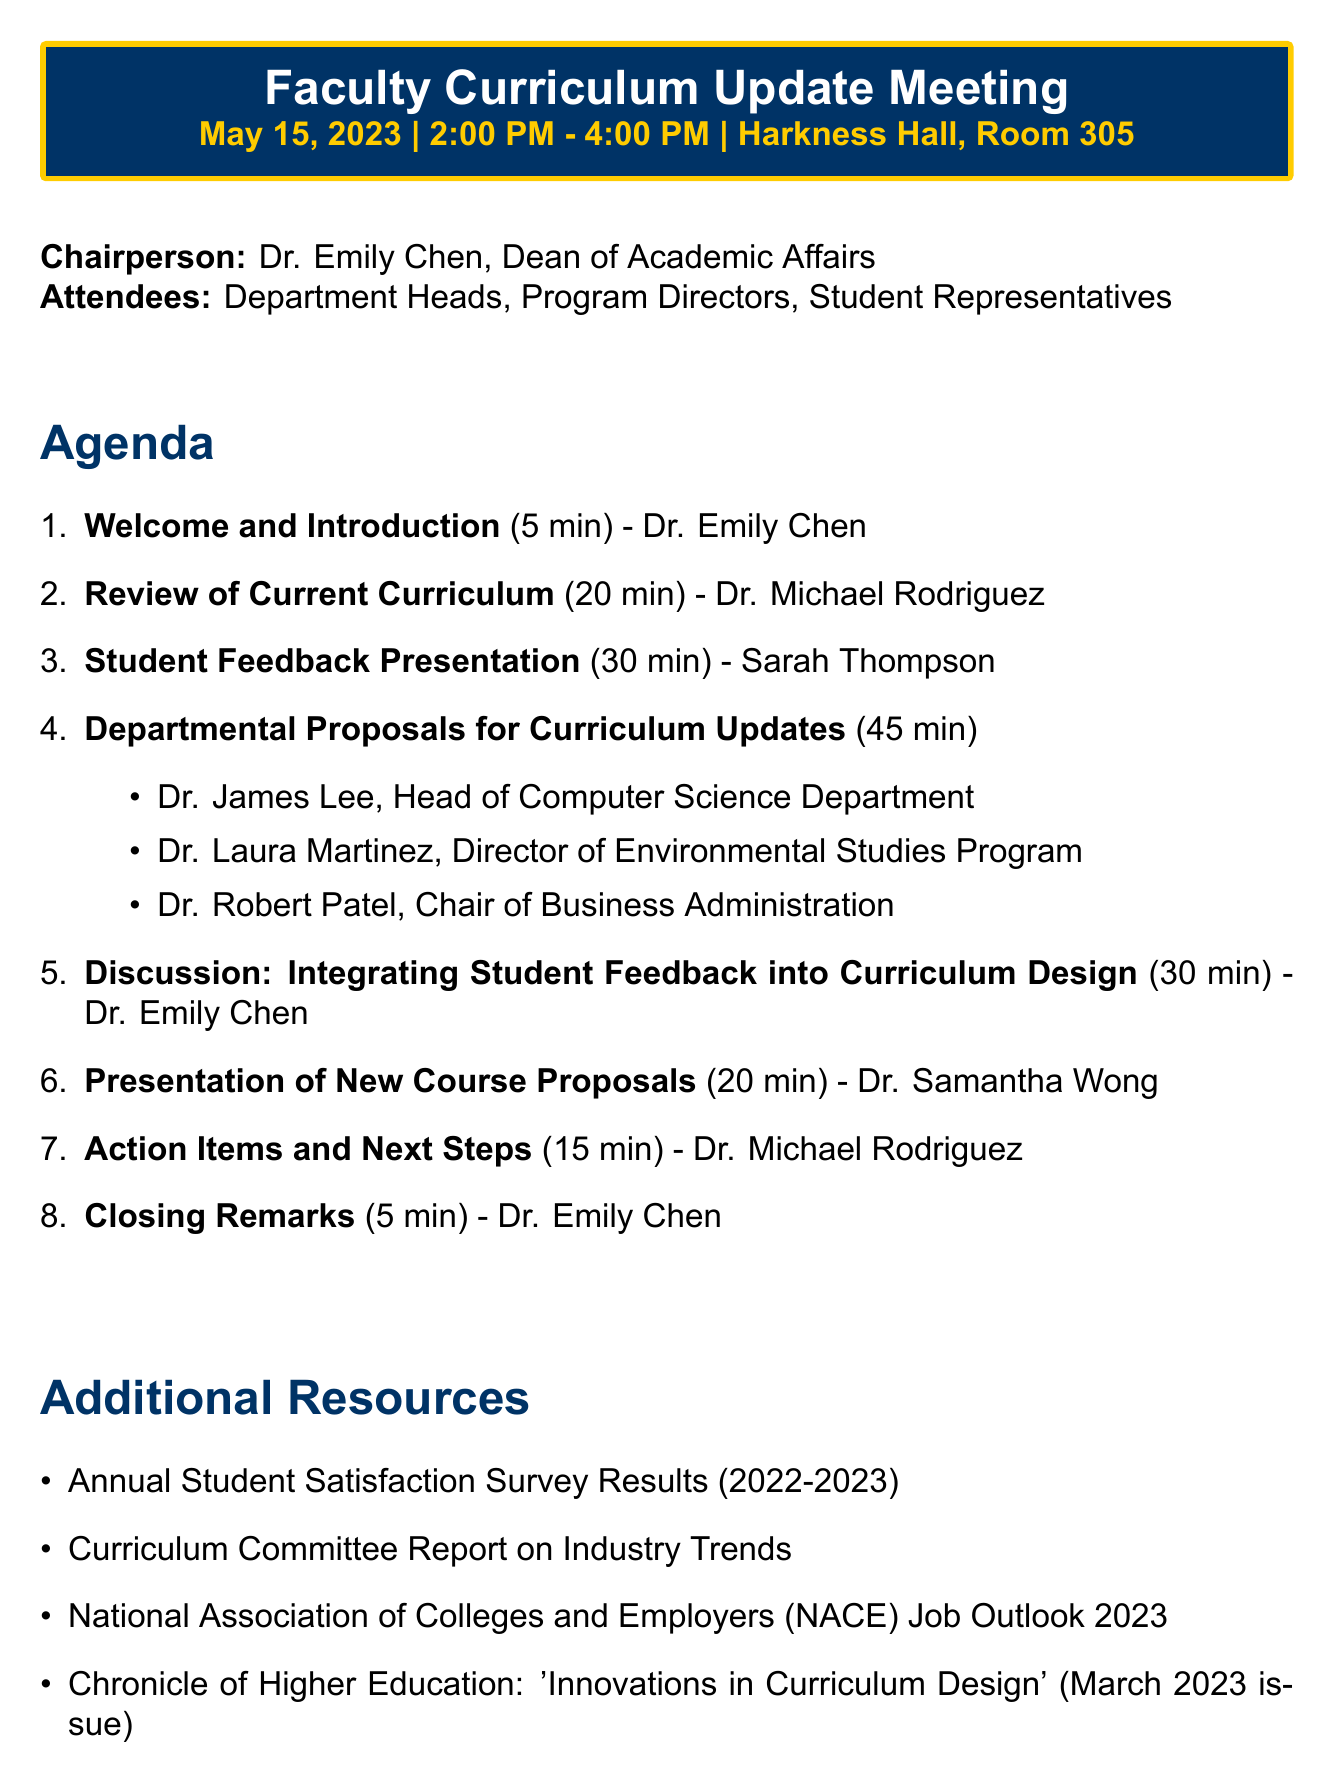What is the date of the meeting? The date of the meeting is listed in the header of the document.
Answer: May 15, 2023 Who is the chairperson of the meeting? The chairperson is identified at the beginning of the document under the chairperson section.
Answer: Dr. Emily Chen How long is the Student Feedback Presentation scheduled for? The duration of the Student Feedback Presentation is specified in the agenda section.
Answer: 30 minutes What is one of the additional resources provided? The additional resources are listed in a specific section of the document.
Answer: Annual Student Satisfaction Survey Results (2022-2023) How many departmental proposals presenters are there? The agenda item mentions the number of presenters for departmental proposals in its description.
Answer: Three What is allocated for the discussion on integrating student feedback? The duration for this discussion is outlined in the agenda section.
Answer: 30 minutes By when are Department Heads required to submit proposals? The deadline for submission is included in the action items section of the document.
Answer: June 1, 2023 Who will present the new course proposals? The agenda lists the presenter's name under the corresponding item.
Answer: Dr. Samantha Wong 